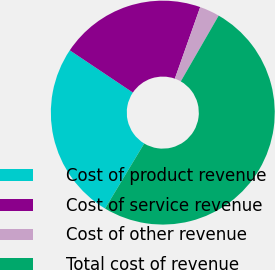Convert chart. <chart><loc_0><loc_0><loc_500><loc_500><pie_chart><fcel>Cost of product revenue<fcel>Cost of service revenue<fcel>Cost of other revenue<fcel>Total cost of revenue<nl><fcel>25.77%<fcel>21.03%<fcel>2.9%<fcel>50.31%<nl></chart> 